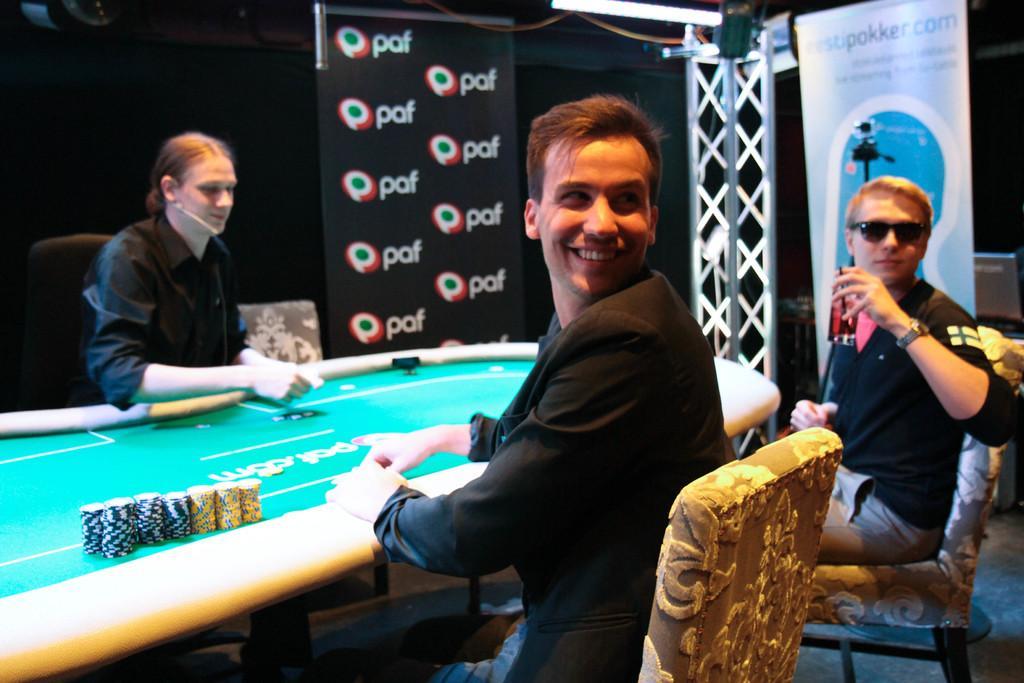Could you give a brief overview of what you see in this image? In this image I see 3 men, in which 2 of them are sitting and one of them is smiling and another one is holding a glass. In the background I see a banner. 